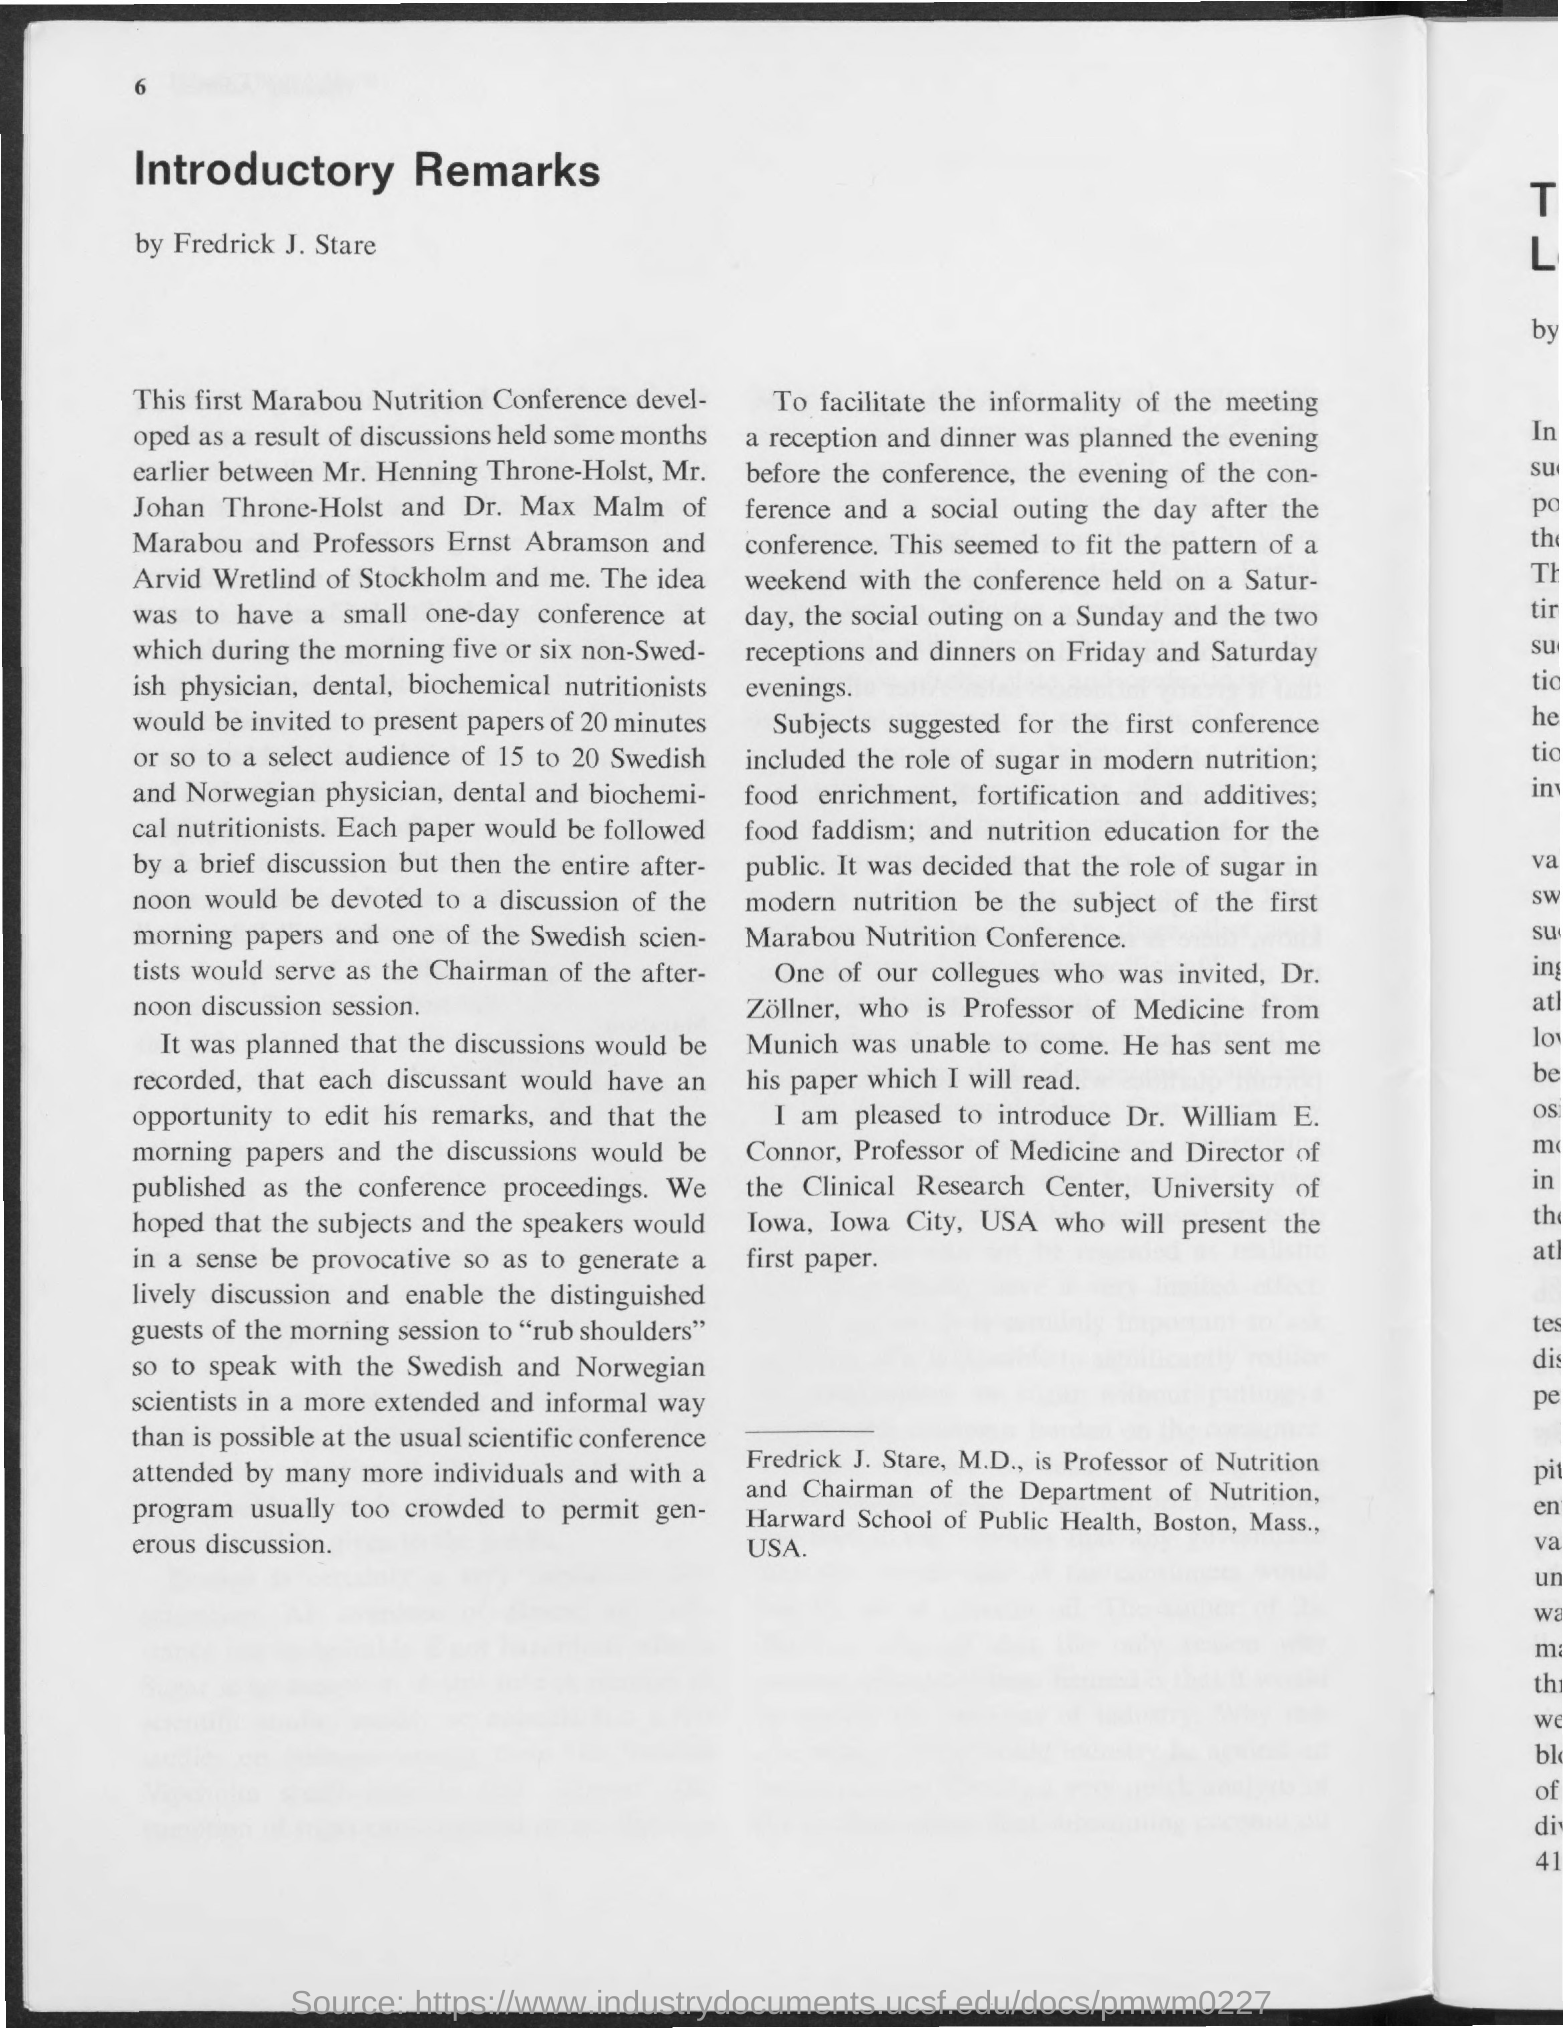Specify some key components in this picture. The title of the document is 'Introductory Remarks.' 